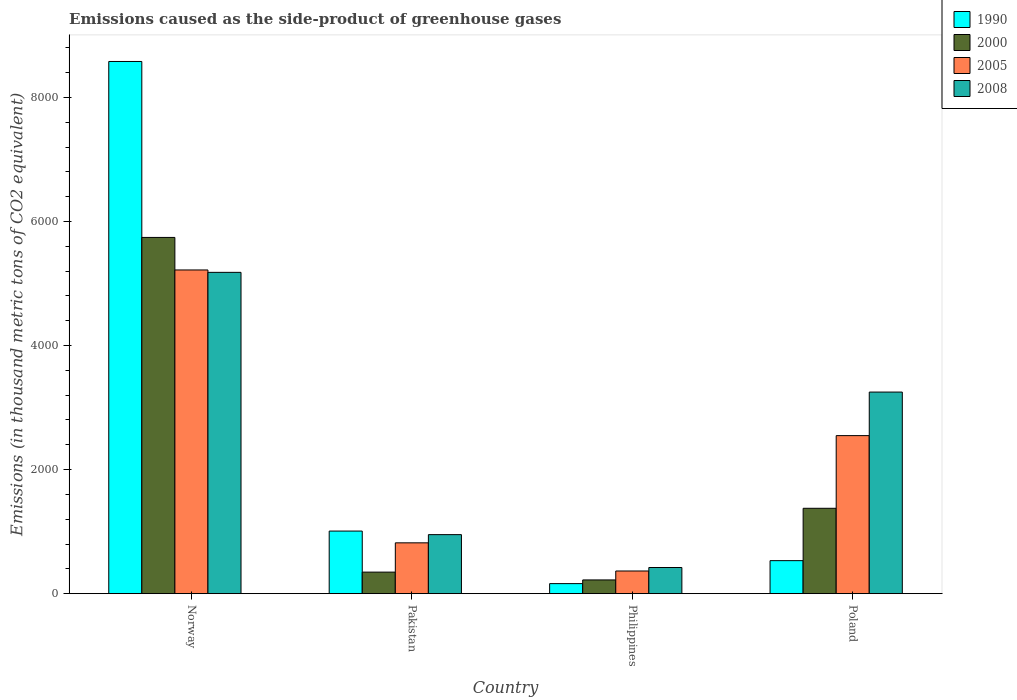How many groups of bars are there?
Offer a terse response. 4. How many bars are there on the 3rd tick from the left?
Provide a short and direct response. 4. How many bars are there on the 4th tick from the right?
Keep it short and to the point. 4. In how many cases, is the number of bars for a given country not equal to the number of legend labels?
Provide a short and direct response. 0. What is the emissions caused as the side-product of greenhouse gases in 2008 in Poland?
Give a very brief answer. 3249.8. Across all countries, what is the maximum emissions caused as the side-product of greenhouse gases in 2008?
Your answer should be very brief. 5179.9. Across all countries, what is the minimum emissions caused as the side-product of greenhouse gases in 2000?
Offer a very short reply. 221.4. In which country was the emissions caused as the side-product of greenhouse gases in 1990 maximum?
Offer a very short reply. Norway. In which country was the emissions caused as the side-product of greenhouse gases in 1990 minimum?
Your answer should be very brief. Philippines. What is the total emissions caused as the side-product of greenhouse gases in 1990 in the graph?
Provide a short and direct response. 1.03e+04. What is the difference between the emissions caused as the side-product of greenhouse gases in 1990 in Pakistan and that in Poland?
Give a very brief answer. 476.8. What is the difference between the emissions caused as the side-product of greenhouse gases in 2005 in Philippines and the emissions caused as the side-product of greenhouse gases in 1990 in Poland?
Provide a short and direct response. -166.9. What is the average emissions caused as the side-product of greenhouse gases in 1990 per country?
Ensure brevity in your answer.  2570.6. What is the difference between the emissions caused as the side-product of greenhouse gases of/in 1990 and emissions caused as the side-product of greenhouse gases of/in 2008 in Poland?
Offer a terse response. -2717.6. What is the ratio of the emissions caused as the side-product of greenhouse gases in 2000 in Norway to that in Pakistan?
Offer a very short reply. 16.54. What is the difference between the highest and the second highest emissions caused as the side-product of greenhouse gases in 2005?
Your response must be concise. -4399.1. What is the difference between the highest and the lowest emissions caused as the side-product of greenhouse gases in 2008?
Your response must be concise. 4758.2. Is it the case that in every country, the sum of the emissions caused as the side-product of greenhouse gases in 1990 and emissions caused as the side-product of greenhouse gases in 2008 is greater than the sum of emissions caused as the side-product of greenhouse gases in 2005 and emissions caused as the side-product of greenhouse gases in 2000?
Offer a terse response. No. How many bars are there?
Offer a very short reply. 16. Are all the bars in the graph horizontal?
Your answer should be compact. No. How many countries are there in the graph?
Provide a short and direct response. 4. What is the difference between two consecutive major ticks on the Y-axis?
Keep it short and to the point. 2000. Does the graph contain grids?
Provide a succinct answer. No. How many legend labels are there?
Ensure brevity in your answer.  4. What is the title of the graph?
Your answer should be compact. Emissions caused as the side-product of greenhouse gases. Does "2000" appear as one of the legend labels in the graph?
Ensure brevity in your answer.  Yes. What is the label or title of the Y-axis?
Offer a terse response. Emissions (in thousand metric tons of CO2 equivalent). What is the Emissions (in thousand metric tons of CO2 equivalent) in 1990 in Norway?
Keep it short and to the point. 8579.3. What is the Emissions (in thousand metric tons of CO2 equivalent) in 2000 in Norway?
Give a very brief answer. 5742.8. What is the Emissions (in thousand metric tons of CO2 equivalent) in 2005 in Norway?
Make the answer very short. 5218.5. What is the Emissions (in thousand metric tons of CO2 equivalent) of 2008 in Norway?
Your answer should be compact. 5179.9. What is the Emissions (in thousand metric tons of CO2 equivalent) of 1990 in Pakistan?
Provide a succinct answer. 1009. What is the Emissions (in thousand metric tons of CO2 equivalent) in 2000 in Pakistan?
Make the answer very short. 347.2. What is the Emissions (in thousand metric tons of CO2 equivalent) in 2005 in Pakistan?
Offer a very short reply. 819.4. What is the Emissions (in thousand metric tons of CO2 equivalent) in 2008 in Pakistan?
Provide a short and direct response. 951.6. What is the Emissions (in thousand metric tons of CO2 equivalent) in 1990 in Philippines?
Offer a terse response. 161.9. What is the Emissions (in thousand metric tons of CO2 equivalent) in 2000 in Philippines?
Ensure brevity in your answer.  221.4. What is the Emissions (in thousand metric tons of CO2 equivalent) in 2005 in Philippines?
Provide a short and direct response. 365.3. What is the Emissions (in thousand metric tons of CO2 equivalent) in 2008 in Philippines?
Provide a short and direct response. 421.7. What is the Emissions (in thousand metric tons of CO2 equivalent) of 1990 in Poland?
Provide a short and direct response. 532.2. What is the Emissions (in thousand metric tons of CO2 equivalent) of 2000 in Poland?
Give a very brief answer. 1376.3. What is the Emissions (in thousand metric tons of CO2 equivalent) in 2005 in Poland?
Keep it short and to the point. 2547.9. What is the Emissions (in thousand metric tons of CO2 equivalent) in 2008 in Poland?
Ensure brevity in your answer.  3249.8. Across all countries, what is the maximum Emissions (in thousand metric tons of CO2 equivalent) of 1990?
Ensure brevity in your answer.  8579.3. Across all countries, what is the maximum Emissions (in thousand metric tons of CO2 equivalent) in 2000?
Provide a succinct answer. 5742.8. Across all countries, what is the maximum Emissions (in thousand metric tons of CO2 equivalent) of 2005?
Give a very brief answer. 5218.5. Across all countries, what is the maximum Emissions (in thousand metric tons of CO2 equivalent) in 2008?
Ensure brevity in your answer.  5179.9. Across all countries, what is the minimum Emissions (in thousand metric tons of CO2 equivalent) in 1990?
Your answer should be very brief. 161.9. Across all countries, what is the minimum Emissions (in thousand metric tons of CO2 equivalent) of 2000?
Offer a terse response. 221.4. Across all countries, what is the minimum Emissions (in thousand metric tons of CO2 equivalent) in 2005?
Your response must be concise. 365.3. Across all countries, what is the minimum Emissions (in thousand metric tons of CO2 equivalent) in 2008?
Give a very brief answer. 421.7. What is the total Emissions (in thousand metric tons of CO2 equivalent) in 1990 in the graph?
Provide a succinct answer. 1.03e+04. What is the total Emissions (in thousand metric tons of CO2 equivalent) in 2000 in the graph?
Your answer should be compact. 7687.7. What is the total Emissions (in thousand metric tons of CO2 equivalent) of 2005 in the graph?
Keep it short and to the point. 8951.1. What is the total Emissions (in thousand metric tons of CO2 equivalent) of 2008 in the graph?
Offer a very short reply. 9803. What is the difference between the Emissions (in thousand metric tons of CO2 equivalent) in 1990 in Norway and that in Pakistan?
Provide a short and direct response. 7570.3. What is the difference between the Emissions (in thousand metric tons of CO2 equivalent) of 2000 in Norway and that in Pakistan?
Make the answer very short. 5395.6. What is the difference between the Emissions (in thousand metric tons of CO2 equivalent) in 2005 in Norway and that in Pakistan?
Your response must be concise. 4399.1. What is the difference between the Emissions (in thousand metric tons of CO2 equivalent) of 2008 in Norway and that in Pakistan?
Keep it short and to the point. 4228.3. What is the difference between the Emissions (in thousand metric tons of CO2 equivalent) in 1990 in Norway and that in Philippines?
Provide a succinct answer. 8417.4. What is the difference between the Emissions (in thousand metric tons of CO2 equivalent) of 2000 in Norway and that in Philippines?
Keep it short and to the point. 5521.4. What is the difference between the Emissions (in thousand metric tons of CO2 equivalent) in 2005 in Norway and that in Philippines?
Your response must be concise. 4853.2. What is the difference between the Emissions (in thousand metric tons of CO2 equivalent) of 2008 in Norway and that in Philippines?
Give a very brief answer. 4758.2. What is the difference between the Emissions (in thousand metric tons of CO2 equivalent) in 1990 in Norway and that in Poland?
Keep it short and to the point. 8047.1. What is the difference between the Emissions (in thousand metric tons of CO2 equivalent) of 2000 in Norway and that in Poland?
Your answer should be compact. 4366.5. What is the difference between the Emissions (in thousand metric tons of CO2 equivalent) of 2005 in Norway and that in Poland?
Offer a terse response. 2670.6. What is the difference between the Emissions (in thousand metric tons of CO2 equivalent) of 2008 in Norway and that in Poland?
Ensure brevity in your answer.  1930.1. What is the difference between the Emissions (in thousand metric tons of CO2 equivalent) in 1990 in Pakistan and that in Philippines?
Provide a succinct answer. 847.1. What is the difference between the Emissions (in thousand metric tons of CO2 equivalent) of 2000 in Pakistan and that in Philippines?
Give a very brief answer. 125.8. What is the difference between the Emissions (in thousand metric tons of CO2 equivalent) of 2005 in Pakistan and that in Philippines?
Offer a terse response. 454.1. What is the difference between the Emissions (in thousand metric tons of CO2 equivalent) of 2008 in Pakistan and that in Philippines?
Offer a terse response. 529.9. What is the difference between the Emissions (in thousand metric tons of CO2 equivalent) of 1990 in Pakistan and that in Poland?
Provide a succinct answer. 476.8. What is the difference between the Emissions (in thousand metric tons of CO2 equivalent) of 2000 in Pakistan and that in Poland?
Your answer should be compact. -1029.1. What is the difference between the Emissions (in thousand metric tons of CO2 equivalent) in 2005 in Pakistan and that in Poland?
Offer a terse response. -1728.5. What is the difference between the Emissions (in thousand metric tons of CO2 equivalent) of 2008 in Pakistan and that in Poland?
Provide a short and direct response. -2298.2. What is the difference between the Emissions (in thousand metric tons of CO2 equivalent) of 1990 in Philippines and that in Poland?
Provide a succinct answer. -370.3. What is the difference between the Emissions (in thousand metric tons of CO2 equivalent) of 2000 in Philippines and that in Poland?
Ensure brevity in your answer.  -1154.9. What is the difference between the Emissions (in thousand metric tons of CO2 equivalent) of 2005 in Philippines and that in Poland?
Keep it short and to the point. -2182.6. What is the difference between the Emissions (in thousand metric tons of CO2 equivalent) in 2008 in Philippines and that in Poland?
Provide a short and direct response. -2828.1. What is the difference between the Emissions (in thousand metric tons of CO2 equivalent) of 1990 in Norway and the Emissions (in thousand metric tons of CO2 equivalent) of 2000 in Pakistan?
Give a very brief answer. 8232.1. What is the difference between the Emissions (in thousand metric tons of CO2 equivalent) of 1990 in Norway and the Emissions (in thousand metric tons of CO2 equivalent) of 2005 in Pakistan?
Ensure brevity in your answer.  7759.9. What is the difference between the Emissions (in thousand metric tons of CO2 equivalent) in 1990 in Norway and the Emissions (in thousand metric tons of CO2 equivalent) in 2008 in Pakistan?
Ensure brevity in your answer.  7627.7. What is the difference between the Emissions (in thousand metric tons of CO2 equivalent) of 2000 in Norway and the Emissions (in thousand metric tons of CO2 equivalent) of 2005 in Pakistan?
Your answer should be very brief. 4923.4. What is the difference between the Emissions (in thousand metric tons of CO2 equivalent) of 2000 in Norway and the Emissions (in thousand metric tons of CO2 equivalent) of 2008 in Pakistan?
Your answer should be very brief. 4791.2. What is the difference between the Emissions (in thousand metric tons of CO2 equivalent) in 2005 in Norway and the Emissions (in thousand metric tons of CO2 equivalent) in 2008 in Pakistan?
Ensure brevity in your answer.  4266.9. What is the difference between the Emissions (in thousand metric tons of CO2 equivalent) of 1990 in Norway and the Emissions (in thousand metric tons of CO2 equivalent) of 2000 in Philippines?
Your answer should be compact. 8357.9. What is the difference between the Emissions (in thousand metric tons of CO2 equivalent) in 1990 in Norway and the Emissions (in thousand metric tons of CO2 equivalent) in 2005 in Philippines?
Offer a terse response. 8214. What is the difference between the Emissions (in thousand metric tons of CO2 equivalent) in 1990 in Norway and the Emissions (in thousand metric tons of CO2 equivalent) in 2008 in Philippines?
Make the answer very short. 8157.6. What is the difference between the Emissions (in thousand metric tons of CO2 equivalent) of 2000 in Norway and the Emissions (in thousand metric tons of CO2 equivalent) of 2005 in Philippines?
Give a very brief answer. 5377.5. What is the difference between the Emissions (in thousand metric tons of CO2 equivalent) in 2000 in Norway and the Emissions (in thousand metric tons of CO2 equivalent) in 2008 in Philippines?
Your answer should be compact. 5321.1. What is the difference between the Emissions (in thousand metric tons of CO2 equivalent) of 2005 in Norway and the Emissions (in thousand metric tons of CO2 equivalent) of 2008 in Philippines?
Your answer should be very brief. 4796.8. What is the difference between the Emissions (in thousand metric tons of CO2 equivalent) of 1990 in Norway and the Emissions (in thousand metric tons of CO2 equivalent) of 2000 in Poland?
Provide a succinct answer. 7203. What is the difference between the Emissions (in thousand metric tons of CO2 equivalent) in 1990 in Norway and the Emissions (in thousand metric tons of CO2 equivalent) in 2005 in Poland?
Your answer should be compact. 6031.4. What is the difference between the Emissions (in thousand metric tons of CO2 equivalent) of 1990 in Norway and the Emissions (in thousand metric tons of CO2 equivalent) of 2008 in Poland?
Keep it short and to the point. 5329.5. What is the difference between the Emissions (in thousand metric tons of CO2 equivalent) of 2000 in Norway and the Emissions (in thousand metric tons of CO2 equivalent) of 2005 in Poland?
Make the answer very short. 3194.9. What is the difference between the Emissions (in thousand metric tons of CO2 equivalent) of 2000 in Norway and the Emissions (in thousand metric tons of CO2 equivalent) of 2008 in Poland?
Ensure brevity in your answer.  2493. What is the difference between the Emissions (in thousand metric tons of CO2 equivalent) of 2005 in Norway and the Emissions (in thousand metric tons of CO2 equivalent) of 2008 in Poland?
Ensure brevity in your answer.  1968.7. What is the difference between the Emissions (in thousand metric tons of CO2 equivalent) in 1990 in Pakistan and the Emissions (in thousand metric tons of CO2 equivalent) in 2000 in Philippines?
Make the answer very short. 787.6. What is the difference between the Emissions (in thousand metric tons of CO2 equivalent) in 1990 in Pakistan and the Emissions (in thousand metric tons of CO2 equivalent) in 2005 in Philippines?
Your answer should be compact. 643.7. What is the difference between the Emissions (in thousand metric tons of CO2 equivalent) of 1990 in Pakistan and the Emissions (in thousand metric tons of CO2 equivalent) of 2008 in Philippines?
Give a very brief answer. 587.3. What is the difference between the Emissions (in thousand metric tons of CO2 equivalent) in 2000 in Pakistan and the Emissions (in thousand metric tons of CO2 equivalent) in 2005 in Philippines?
Provide a succinct answer. -18.1. What is the difference between the Emissions (in thousand metric tons of CO2 equivalent) in 2000 in Pakistan and the Emissions (in thousand metric tons of CO2 equivalent) in 2008 in Philippines?
Your response must be concise. -74.5. What is the difference between the Emissions (in thousand metric tons of CO2 equivalent) in 2005 in Pakistan and the Emissions (in thousand metric tons of CO2 equivalent) in 2008 in Philippines?
Offer a very short reply. 397.7. What is the difference between the Emissions (in thousand metric tons of CO2 equivalent) of 1990 in Pakistan and the Emissions (in thousand metric tons of CO2 equivalent) of 2000 in Poland?
Your answer should be compact. -367.3. What is the difference between the Emissions (in thousand metric tons of CO2 equivalent) of 1990 in Pakistan and the Emissions (in thousand metric tons of CO2 equivalent) of 2005 in Poland?
Ensure brevity in your answer.  -1538.9. What is the difference between the Emissions (in thousand metric tons of CO2 equivalent) in 1990 in Pakistan and the Emissions (in thousand metric tons of CO2 equivalent) in 2008 in Poland?
Your answer should be compact. -2240.8. What is the difference between the Emissions (in thousand metric tons of CO2 equivalent) in 2000 in Pakistan and the Emissions (in thousand metric tons of CO2 equivalent) in 2005 in Poland?
Offer a terse response. -2200.7. What is the difference between the Emissions (in thousand metric tons of CO2 equivalent) in 2000 in Pakistan and the Emissions (in thousand metric tons of CO2 equivalent) in 2008 in Poland?
Make the answer very short. -2902.6. What is the difference between the Emissions (in thousand metric tons of CO2 equivalent) of 2005 in Pakistan and the Emissions (in thousand metric tons of CO2 equivalent) of 2008 in Poland?
Your answer should be very brief. -2430.4. What is the difference between the Emissions (in thousand metric tons of CO2 equivalent) of 1990 in Philippines and the Emissions (in thousand metric tons of CO2 equivalent) of 2000 in Poland?
Give a very brief answer. -1214.4. What is the difference between the Emissions (in thousand metric tons of CO2 equivalent) of 1990 in Philippines and the Emissions (in thousand metric tons of CO2 equivalent) of 2005 in Poland?
Give a very brief answer. -2386. What is the difference between the Emissions (in thousand metric tons of CO2 equivalent) in 1990 in Philippines and the Emissions (in thousand metric tons of CO2 equivalent) in 2008 in Poland?
Ensure brevity in your answer.  -3087.9. What is the difference between the Emissions (in thousand metric tons of CO2 equivalent) of 2000 in Philippines and the Emissions (in thousand metric tons of CO2 equivalent) of 2005 in Poland?
Give a very brief answer. -2326.5. What is the difference between the Emissions (in thousand metric tons of CO2 equivalent) in 2000 in Philippines and the Emissions (in thousand metric tons of CO2 equivalent) in 2008 in Poland?
Your answer should be very brief. -3028.4. What is the difference between the Emissions (in thousand metric tons of CO2 equivalent) in 2005 in Philippines and the Emissions (in thousand metric tons of CO2 equivalent) in 2008 in Poland?
Make the answer very short. -2884.5. What is the average Emissions (in thousand metric tons of CO2 equivalent) in 1990 per country?
Ensure brevity in your answer.  2570.6. What is the average Emissions (in thousand metric tons of CO2 equivalent) of 2000 per country?
Offer a very short reply. 1921.92. What is the average Emissions (in thousand metric tons of CO2 equivalent) of 2005 per country?
Offer a very short reply. 2237.78. What is the average Emissions (in thousand metric tons of CO2 equivalent) of 2008 per country?
Provide a succinct answer. 2450.75. What is the difference between the Emissions (in thousand metric tons of CO2 equivalent) of 1990 and Emissions (in thousand metric tons of CO2 equivalent) of 2000 in Norway?
Ensure brevity in your answer.  2836.5. What is the difference between the Emissions (in thousand metric tons of CO2 equivalent) in 1990 and Emissions (in thousand metric tons of CO2 equivalent) in 2005 in Norway?
Ensure brevity in your answer.  3360.8. What is the difference between the Emissions (in thousand metric tons of CO2 equivalent) in 1990 and Emissions (in thousand metric tons of CO2 equivalent) in 2008 in Norway?
Offer a terse response. 3399.4. What is the difference between the Emissions (in thousand metric tons of CO2 equivalent) in 2000 and Emissions (in thousand metric tons of CO2 equivalent) in 2005 in Norway?
Your answer should be very brief. 524.3. What is the difference between the Emissions (in thousand metric tons of CO2 equivalent) of 2000 and Emissions (in thousand metric tons of CO2 equivalent) of 2008 in Norway?
Make the answer very short. 562.9. What is the difference between the Emissions (in thousand metric tons of CO2 equivalent) in 2005 and Emissions (in thousand metric tons of CO2 equivalent) in 2008 in Norway?
Ensure brevity in your answer.  38.6. What is the difference between the Emissions (in thousand metric tons of CO2 equivalent) in 1990 and Emissions (in thousand metric tons of CO2 equivalent) in 2000 in Pakistan?
Your response must be concise. 661.8. What is the difference between the Emissions (in thousand metric tons of CO2 equivalent) of 1990 and Emissions (in thousand metric tons of CO2 equivalent) of 2005 in Pakistan?
Keep it short and to the point. 189.6. What is the difference between the Emissions (in thousand metric tons of CO2 equivalent) of 1990 and Emissions (in thousand metric tons of CO2 equivalent) of 2008 in Pakistan?
Ensure brevity in your answer.  57.4. What is the difference between the Emissions (in thousand metric tons of CO2 equivalent) in 2000 and Emissions (in thousand metric tons of CO2 equivalent) in 2005 in Pakistan?
Your response must be concise. -472.2. What is the difference between the Emissions (in thousand metric tons of CO2 equivalent) in 2000 and Emissions (in thousand metric tons of CO2 equivalent) in 2008 in Pakistan?
Your response must be concise. -604.4. What is the difference between the Emissions (in thousand metric tons of CO2 equivalent) in 2005 and Emissions (in thousand metric tons of CO2 equivalent) in 2008 in Pakistan?
Your answer should be very brief. -132.2. What is the difference between the Emissions (in thousand metric tons of CO2 equivalent) of 1990 and Emissions (in thousand metric tons of CO2 equivalent) of 2000 in Philippines?
Offer a very short reply. -59.5. What is the difference between the Emissions (in thousand metric tons of CO2 equivalent) of 1990 and Emissions (in thousand metric tons of CO2 equivalent) of 2005 in Philippines?
Your response must be concise. -203.4. What is the difference between the Emissions (in thousand metric tons of CO2 equivalent) in 1990 and Emissions (in thousand metric tons of CO2 equivalent) in 2008 in Philippines?
Keep it short and to the point. -259.8. What is the difference between the Emissions (in thousand metric tons of CO2 equivalent) in 2000 and Emissions (in thousand metric tons of CO2 equivalent) in 2005 in Philippines?
Provide a short and direct response. -143.9. What is the difference between the Emissions (in thousand metric tons of CO2 equivalent) in 2000 and Emissions (in thousand metric tons of CO2 equivalent) in 2008 in Philippines?
Provide a short and direct response. -200.3. What is the difference between the Emissions (in thousand metric tons of CO2 equivalent) of 2005 and Emissions (in thousand metric tons of CO2 equivalent) of 2008 in Philippines?
Ensure brevity in your answer.  -56.4. What is the difference between the Emissions (in thousand metric tons of CO2 equivalent) in 1990 and Emissions (in thousand metric tons of CO2 equivalent) in 2000 in Poland?
Provide a succinct answer. -844.1. What is the difference between the Emissions (in thousand metric tons of CO2 equivalent) of 1990 and Emissions (in thousand metric tons of CO2 equivalent) of 2005 in Poland?
Keep it short and to the point. -2015.7. What is the difference between the Emissions (in thousand metric tons of CO2 equivalent) of 1990 and Emissions (in thousand metric tons of CO2 equivalent) of 2008 in Poland?
Provide a succinct answer. -2717.6. What is the difference between the Emissions (in thousand metric tons of CO2 equivalent) of 2000 and Emissions (in thousand metric tons of CO2 equivalent) of 2005 in Poland?
Ensure brevity in your answer.  -1171.6. What is the difference between the Emissions (in thousand metric tons of CO2 equivalent) of 2000 and Emissions (in thousand metric tons of CO2 equivalent) of 2008 in Poland?
Make the answer very short. -1873.5. What is the difference between the Emissions (in thousand metric tons of CO2 equivalent) in 2005 and Emissions (in thousand metric tons of CO2 equivalent) in 2008 in Poland?
Your answer should be very brief. -701.9. What is the ratio of the Emissions (in thousand metric tons of CO2 equivalent) in 1990 in Norway to that in Pakistan?
Your answer should be very brief. 8.5. What is the ratio of the Emissions (in thousand metric tons of CO2 equivalent) of 2000 in Norway to that in Pakistan?
Your answer should be compact. 16.54. What is the ratio of the Emissions (in thousand metric tons of CO2 equivalent) of 2005 in Norway to that in Pakistan?
Offer a terse response. 6.37. What is the ratio of the Emissions (in thousand metric tons of CO2 equivalent) in 2008 in Norway to that in Pakistan?
Ensure brevity in your answer.  5.44. What is the ratio of the Emissions (in thousand metric tons of CO2 equivalent) of 1990 in Norway to that in Philippines?
Keep it short and to the point. 52.99. What is the ratio of the Emissions (in thousand metric tons of CO2 equivalent) of 2000 in Norway to that in Philippines?
Your response must be concise. 25.94. What is the ratio of the Emissions (in thousand metric tons of CO2 equivalent) in 2005 in Norway to that in Philippines?
Your response must be concise. 14.29. What is the ratio of the Emissions (in thousand metric tons of CO2 equivalent) of 2008 in Norway to that in Philippines?
Make the answer very short. 12.28. What is the ratio of the Emissions (in thousand metric tons of CO2 equivalent) of 1990 in Norway to that in Poland?
Provide a short and direct response. 16.12. What is the ratio of the Emissions (in thousand metric tons of CO2 equivalent) of 2000 in Norway to that in Poland?
Keep it short and to the point. 4.17. What is the ratio of the Emissions (in thousand metric tons of CO2 equivalent) of 2005 in Norway to that in Poland?
Make the answer very short. 2.05. What is the ratio of the Emissions (in thousand metric tons of CO2 equivalent) in 2008 in Norway to that in Poland?
Your answer should be compact. 1.59. What is the ratio of the Emissions (in thousand metric tons of CO2 equivalent) of 1990 in Pakistan to that in Philippines?
Provide a succinct answer. 6.23. What is the ratio of the Emissions (in thousand metric tons of CO2 equivalent) of 2000 in Pakistan to that in Philippines?
Your answer should be compact. 1.57. What is the ratio of the Emissions (in thousand metric tons of CO2 equivalent) of 2005 in Pakistan to that in Philippines?
Your response must be concise. 2.24. What is the ratio of the Emissions (in thousand metric tons of CO2 equivalent) of 2008 in Pakistan to that in Philippines?
Offer a terse response. 2.26. What is the ratio of the Emissions (in thousand metric tons of CO2 equivalent) in 1990 in Pakistan to that in Poland?
Your answer should be very brief. 1.9. What is the ratio of the Emissions (in thousand metric tons of CO2 equivalent) of 2000 in Pakistan to that in Poland?
Provide a short and direct response. 0.25. What is the ratio of the Emissions (in thousand metric tons of CO2 equivalent) of 2005 in Pakistan to that in Poland?
Provide a succinct answer. 0.32. What is the ratio of the Emissions (in thousand metric tons of CO2 equivalent) of 2008 in Pakistan to that in Poland?
Your response must be concise. 0.29. What is the ratio of the Emissions (in thousand metric tons of CO2 equivalent) of 1990 in Philippines to that in Poland?
Make the answer very short. 0.3. What is the ratio of the Emissions (in thousand metric tons of CO2 equivalent) in 2000 in Philippines to that in Poland?
Provide a succinct answer. 0.16. What is the ratio of the Emissions (in thousand metric tons of CO2 equivalent) in 2005 in Philippines to that in Poland?
Your response must be concise. 0.14. What is the ratio of the Emissions (in thousand metric tons of CO2 equivalent) in 2008 in Philippines to that in Poland?
Give a very brief answer. 0.13. What is the difference between the highest and the second highest Emissions (in thousand metric tons of CO2 equivalent) of 1990?
Provide a short and direct response. 7570.3. What is the difference between the highest and the second highest Emissions (in thousand metric tons of CO2 equivalent) in 2000?
Offer a very short reply. 4366.5. What is the difference between the highest and the second highest Emissions (in thousand metric tons of CO2 equivalent) in 2005?
Ensure brevity in your answer.  2670.6. What is the difference between the highest and the second highest Emissions (in thousand metric tons of CO2 equivalent) in 2008?
Make the answer very short. 1930.1. What is the difference between the highest and the lowest Emissions (in thousand metric tons of CO2 equivalent) of 1990?
Make the answer very short. 8417.4. What is the difference between the highest and the lowest Emissions (in thousand metric tons of CO2 equivalent) of 2000?
Provide a short and direct response. 5521.4. What is the difference between the highest and the lowest Emissions (in thousand metric tons of CO2 equivalent) in 2005?
Make the answer very short. 4853.2. What is the difference between the highest and the lowest Emissions (in thousand metric tons of CO2 equivalent) of 2008?
Make the answer very short. 4758.2. 